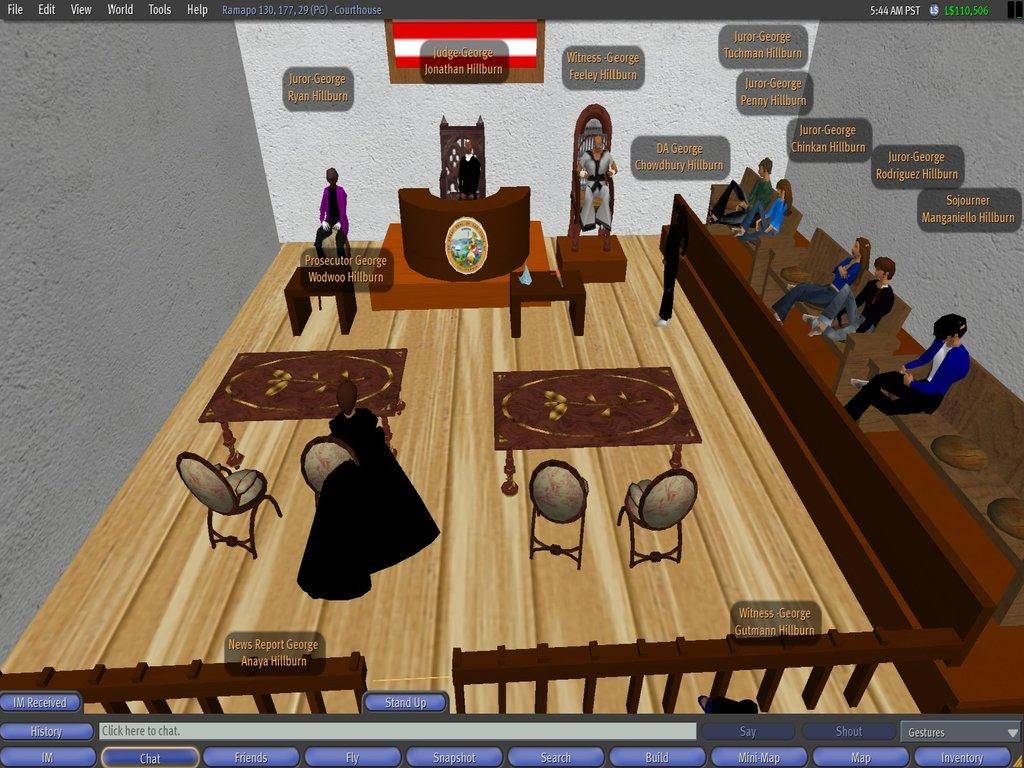What are the people in the image doing? There are persons sitting in the image. Are there any available seats in the image? Yes, there are empty chairs in the image. What type of furniture is present in the image? There are tables in the image. What can be seen written in the image? There is text written in the image. What color is the chalk used to write the text in the image? There is no mention of chalk in the provided facts, so it cannot be determined from the image. 